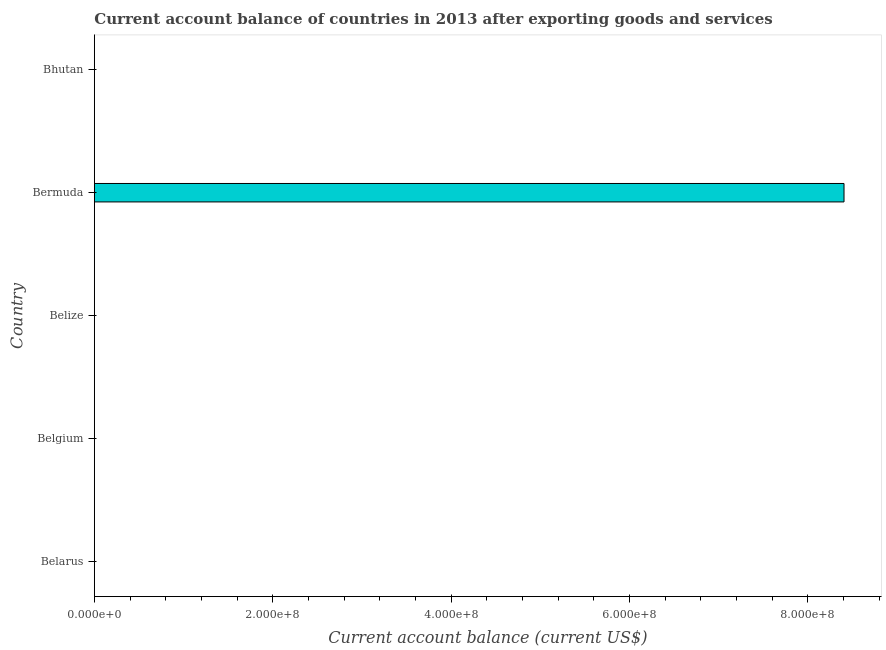Does the graph contain any zero values?
Ensure brevity in your answer.  Yes. Does the graph contain grids?
Your answer should be compact. No. What is the title of the graph?
Provide a succinct answer. Current account balance of countries in 2013 after exporting goods and services. What is the label or title of the X-axis?
Give a very brief answer. Current account balance (current US$). What is the label or title of the Y-axis?
Your answer should be compact. Country. What is the current account balance in Belgium?
Ensure brevity in your answer.  0. Across all countries, what is the maximum current account balance?
Your response must be concise. 8.41e+08. In which country was the current account balance maximum?
Offer a very short reply. Bermuda. What is the sum of the current account balance?
Your response must be concise. 8.41e+08. What is the average current account balance per country?
Keep it short and to the point. 1.68e+08. In how many countries, is the current account balance greater than 760000000 US$?
Your answer should be compact. 1. What is the difference between the highest and the lowest current account balance?
Your answer should be very brief. 8.41e+08. In how many countries, is the current account balance greater than the average current account balance taken over all countries?
Your answer should be very brief. 1. How many bars are there?
Provide a short and direct response. 1. Are all the bars in the graph horizontal?
Keep it short and to the point. Yes. How many countries are there in the graph?
Keep it short and to the point. 5. What is the Current account balance (current US$) in Belize?
Provide a succinct answer. 0. What is the Current account balance (current US$) of Bermuda?
Provide a short and direct response. 8.41e+08. What is the Current account balance (current US$) of Bhutan?
Your response must be concise. 0. 